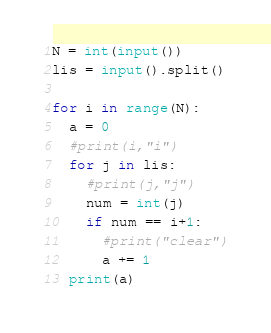Convert code to text. <code><loc_0><loc_0><loc_500><loc_500><_Python_>N = int(input())
lis = input().split()

for i in range(N):
  a = 0
  #print(i,"i")
  for j in lis:
    #print(j,"j")
    num = int(j)
    if num == i+1:
      #print("clear")
      a += 1
  print(a)</code> 